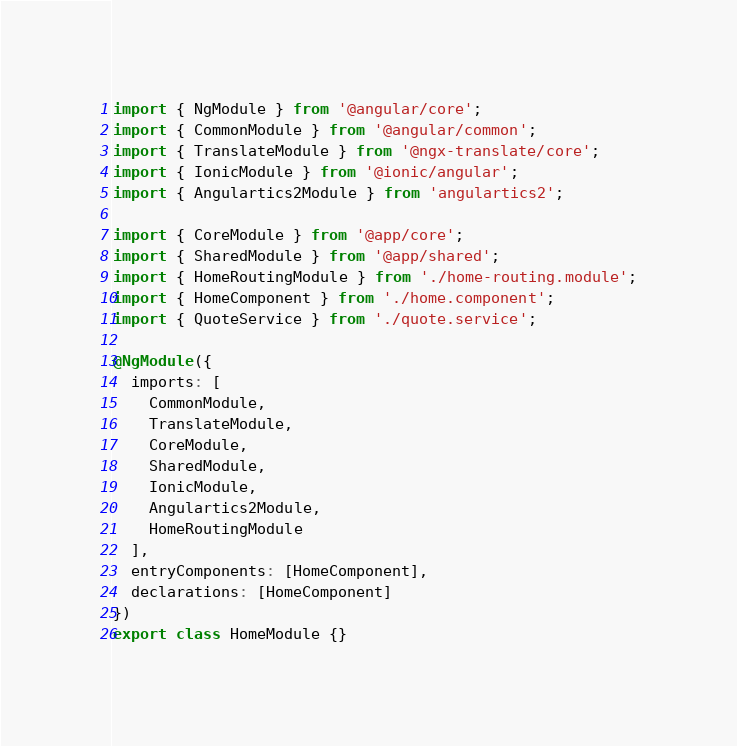Convert code to text. <code><loc_0><loc_0><loc_500><loc_500><_TypeScript_>import { NgModule } from '@angular/core';
import { CommonModule } from '@angular/common';
import { TranslateModule } from '@ngx-translate/core';
import { IonicModule } from '@ionic/angular';
import { Angulartics2Module } from 'angulartics2';

import { CoreModule } from '@app/core';
import { SharedModule } from '@app/shared';
import { HomeRoutingModule } from './home-routing.module';
import { HomeComponent } from './home.component';
import { QuoteService } from './quote.service';

@NgModule({
  imports: [
    CommonModule,
    TranslateModule,
    CoreModule,
    SharedModule,
    IonicModule,
    Angulartics2Module,
    HomeRoutingModule
  ],
  entryComponents: [HomeComponent],
  declarations: [HomeComponent]
})
export class HomeModule {}
</code> 